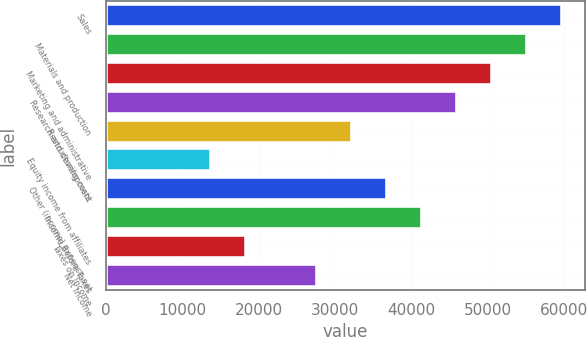<chart> <loc_0><loc_0><loc_500><loc_500><bar_chart><fcel>Sales<fcel>Materials and production<fcel>Marketing and administrative<fcel>Research and development<fcel>Restructuring costs<fcel>Equity income from affiliates<fcel>Other (income) expense net<fcel>Income Before Taxes<fcel>Taxes on Income<fcel>Net Income<nl><fcel>59783<fcel>55184.3<fcel>50585.7<fcel>45987<fcel>32191<fcel>13796.3<fcel>36789.6<fcel>41388.3<fcel>18395<fcel>27592.3<nl></chart> 